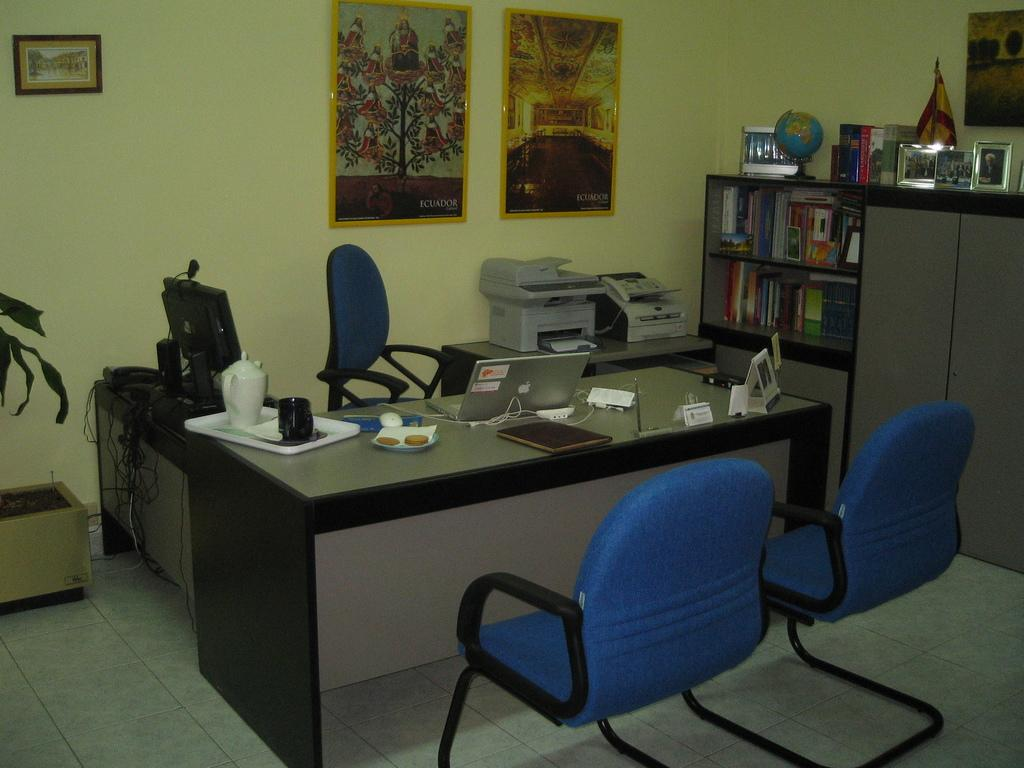What type of room is depicted in the image? The image depicts an office room. What furniture is present in the room? There is a table and chairs in the room. What office equipment can be seen in the room? There is a printer in the room. What items related to knowledge or learning are in the room? There are books and photographs in the room. What decorative item is present in the room? There is a portrait in the room. What item represents the world in the room? There is a globe in the room. What type of plant is on the left side of the image? The plant on the left side of the image is not specified, but it is a plant. Can you see a van driving through the office room in the image? No, there is no van present in the image. Are there any ducks swimming in the plant on the left side of the image? No, there are no ducks present in the image. Is the office room located on an island in the image? No, the image does not show the office room being located on an island. 